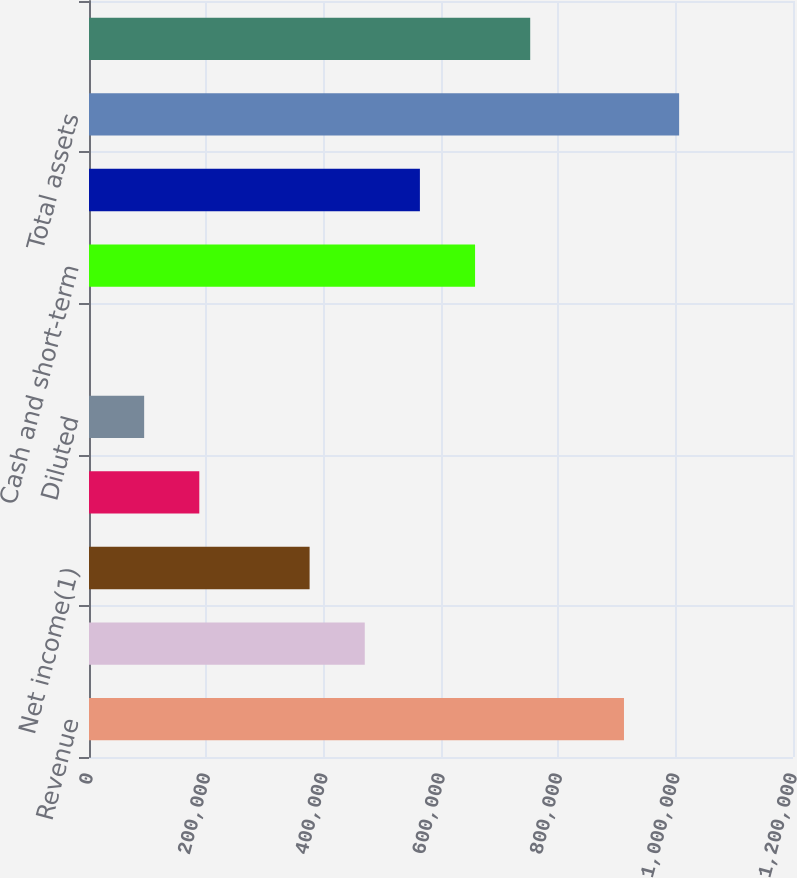<chart> <loc_0><loc_0><loc_500><loc_500><bar_chart><fcel>Revenue<fcel>Income before income taxes<fcel>Net income(1)<fcel>Basic<fcel>Diluted<fcel>Cash dividends declared per<fcel>Cash and short-term<fcel>Working capital<fcel>Total assets<fcel>Stockholders' equity<nl><fcel>911894<fcel>470036<fcel>376028<fcel>188014<fcel>94007.2<fcel>0.1<fcel>658050<fcel>564043<fcel>1.0059e+06<fcel>752057<nl></chart> 